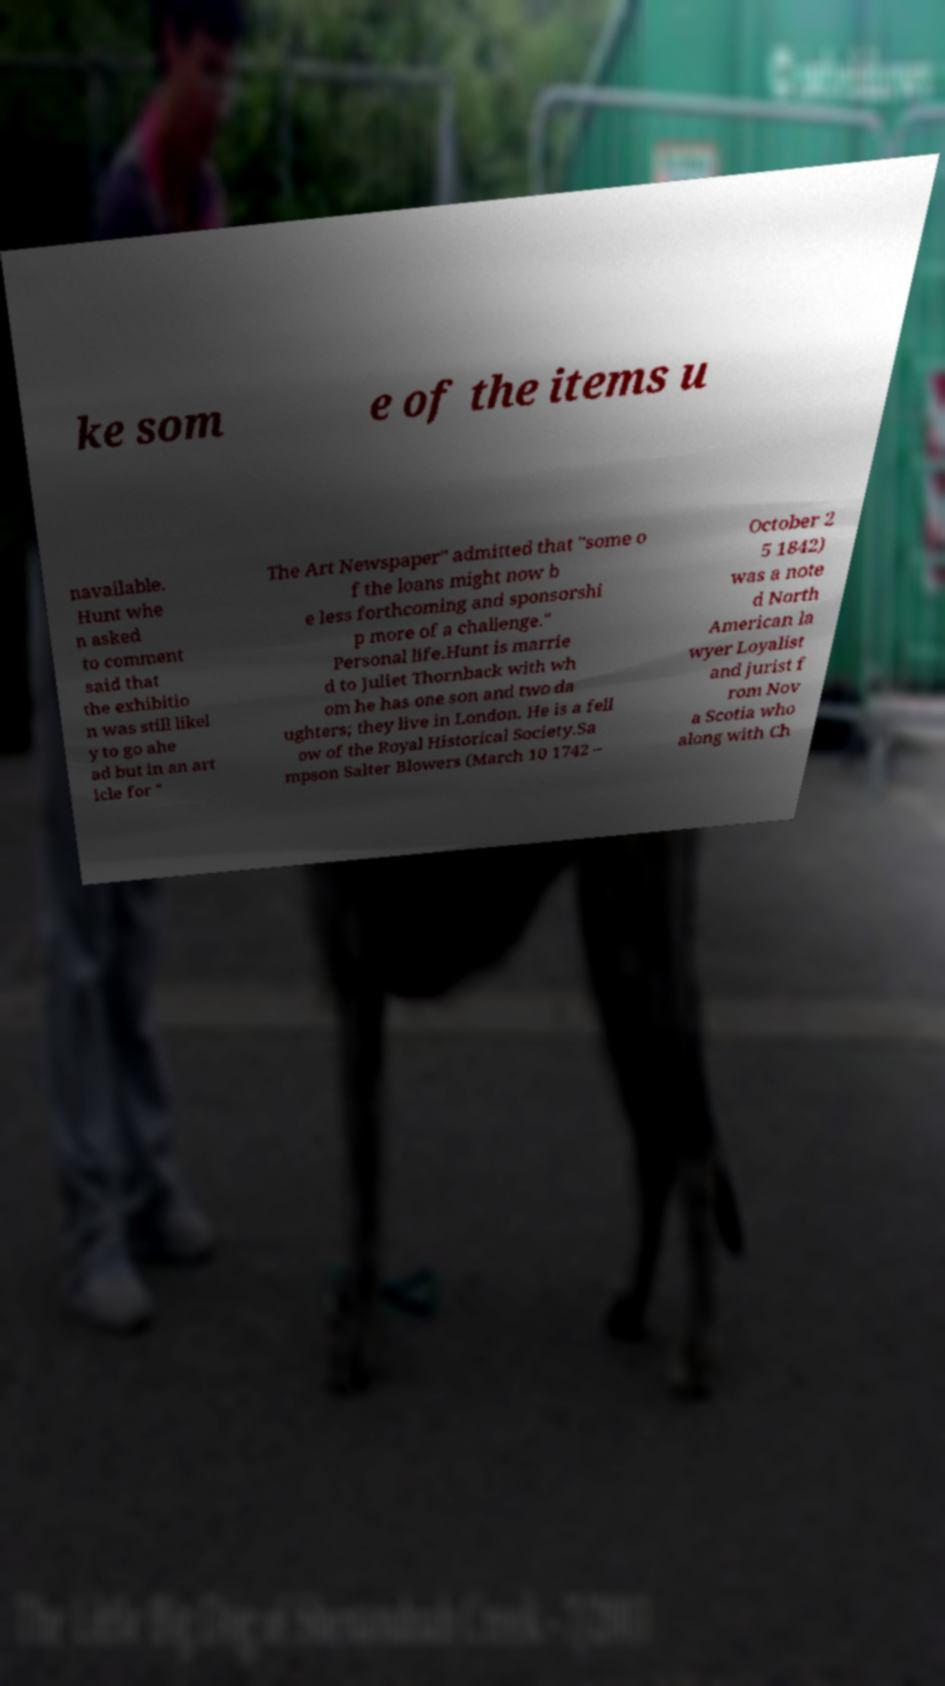Can you read and provide the text displayed in the image?This photo seems to have some interesting text. Can you extract and type it out for me? ke som e of the items u navailable. Hunt whe n asked to comment said that the exhibitio n was still likel y to go ahe ad but in an art icle for " The Art Newspaper" admitted that "some o f the loans might now b e less forthcoming and sponsorshi p more of a challenge." Personal life.Hunt is marrie d to Juliet Thornback with wh om he has one son and two da ughters; they live in London. He is a fell ow of the Royal Historical Society.Sa mpson Salter Blowers (March 10 1742 – October 2 5 1842) was a note d North American la wyer Loyalist and jurist f rom Nov a Scotia who along with Ch 